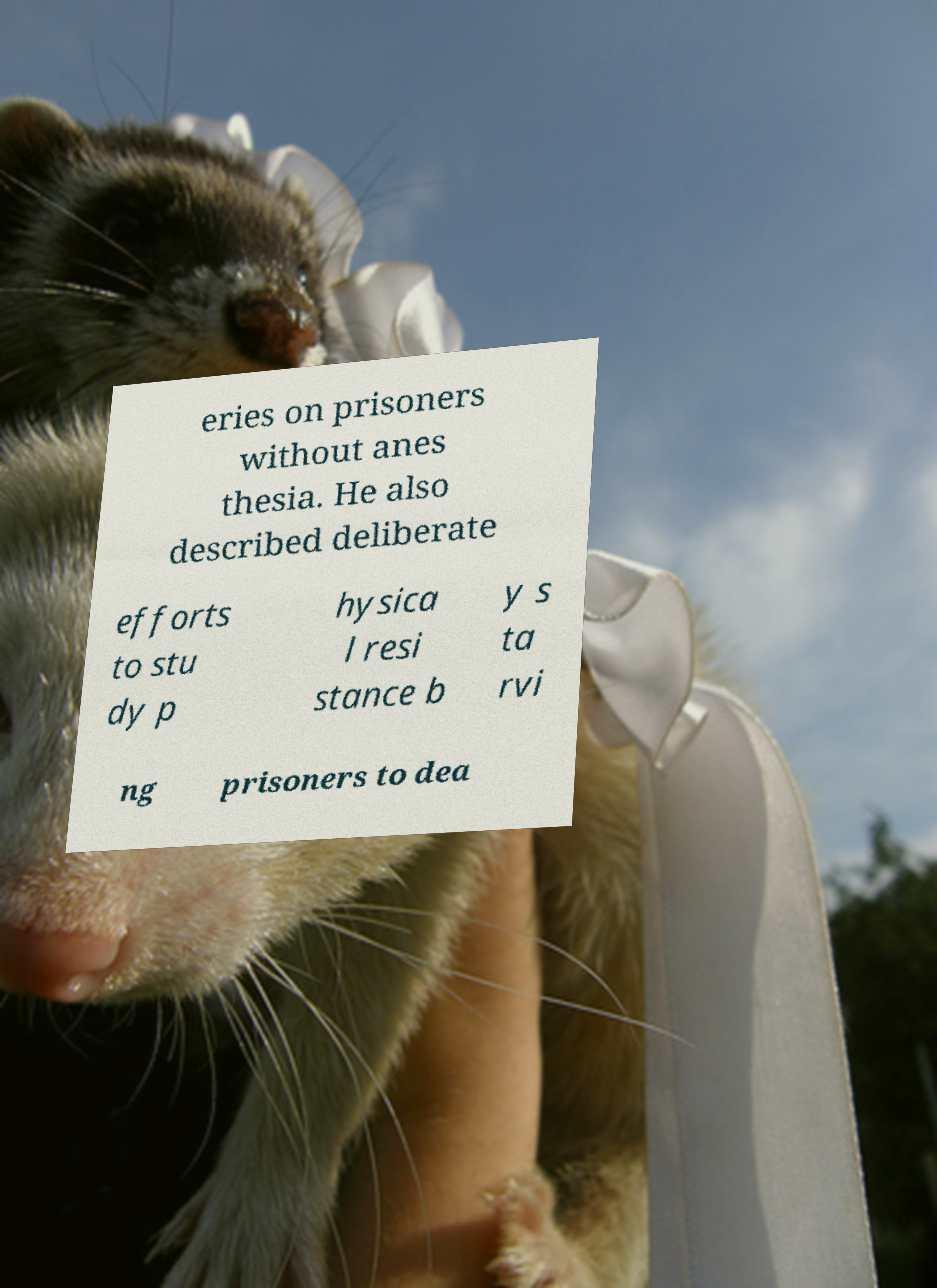What messages or text are displayed in this image? I need them in a readable, typed format. eries on prisoners without anes thesia. He also described deliberate efforts to stu dy p hysica l resi stance b y s ta rvi ng prisoners to dea 